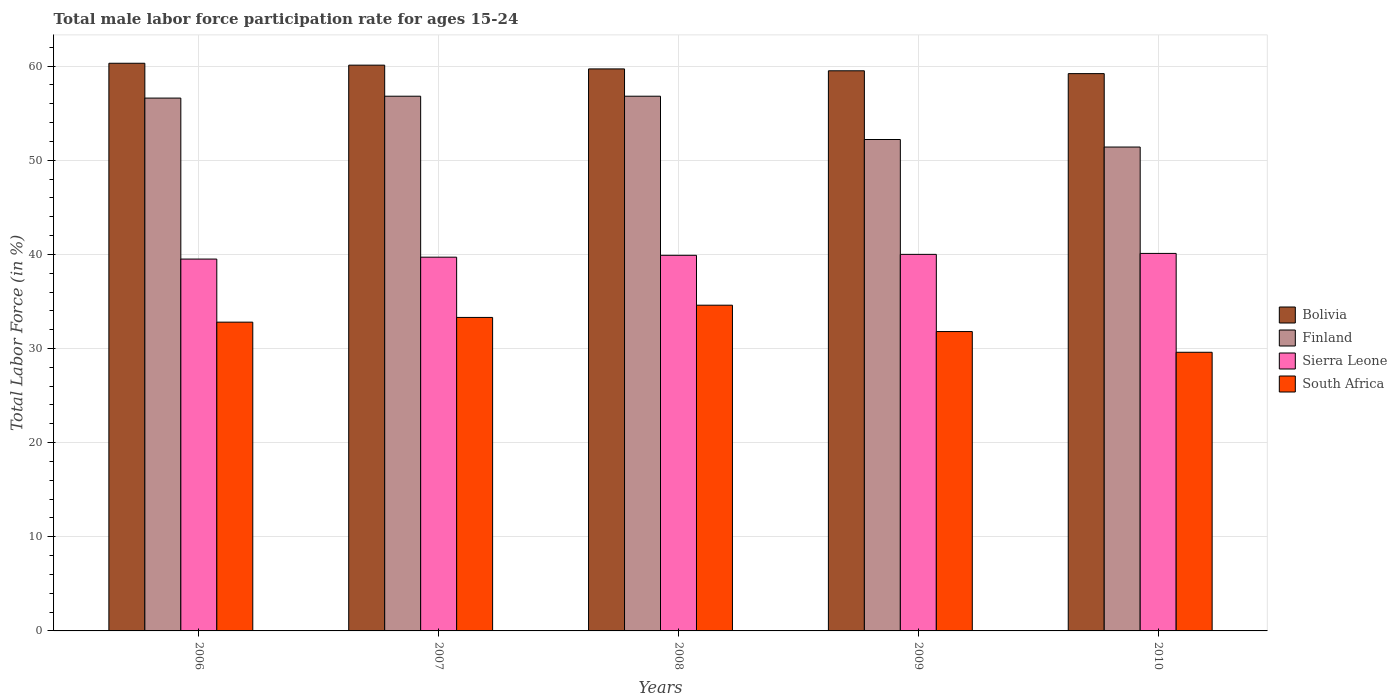How many different coloured bars are there?
Offer a terse response. 4. How many bars are there on the 1st tick from the left?
Provide a succinct answer. 4. How many bars are there on the 1st tick from the right?
Offer a very short reply. 4. What is the label of the 2nd group of bars from the left?
Your response must be concise. 2007. What is the male labor force participation rate in Finland in 2008?
Keep it short and to the point. 56.8. Across all years, what is the maximum male labor force participation rate in South Africa?
Offer a terse response. 34.6. Across all years, what is the minimum male labor force participation rate in Finland?
Give a very brief answer. 51.4. What is the total male labor force participation rate in Finland in the graph?
Ensure brevity in your answer.  273.8. What is the difference between the male labor force participation rate in Bolivia in 2006 and that in 2007?
Your answer should be compact. 0.2. What is the difference between the male labor force participation rate in Finland in 2008 and the male labor force participation rate in Bolivia in 2009?
Ensure brevity in your answer.  -2.7. What is the average male labor force participation rate in South Africa per year?
Provide a short and direct response. 32.42. In the year 2007, what is the difference between the male labor force participation rate in Finland and male labor force participation rate in Bolivia?
Ensure brevity in your answer.  -3.3. What is the ratio of the male labor force participation rate in Bolivia in 2008 to that in 2010?
Offer a very short reply. 1.01. Is the male labor force participation rate in Sierra Leone in 2006 less than that in 2009?
Your response must be concise. Yes. What is the difference between the highest and the second highest male labor force participation rate in Bolivia?
Your answer should be compact. 0.2. What is the difference between the highest and the lowest male labor force participation rate in South Africa?
Offer a terse response. 5. Is the sum of the male labor force participation rate in South Africa in 2009 and 2010 greater than the maximum male labor force participation rate in Bolivia across all years?
Ensure brevity in your answer.  Yes. Is it the case that in every year, the sum of the male labor force participation rate in Bolivia and male labor force participation rate in Sierra Leone is greater than the sum of male labor force participation rate in Finland and male labor force participation rate in South Africa?
Offer a very short reply. No. What does the 2nd bar from the right in 2007 represents?
Keep it short and to the point. Sierra Leone. Is it the case that in every year, the sum of the male labor force participation rate in Bolivia and male labor force participation rate in Finland is greater than the male labor force participation rate in Sierra Leone?
Provide a short and direct response. Yes. How many bars are there?
Provide a succinct answer. 20. How many years are there in the graph?
Ensure brevity in your answer.  5. Are the values on the major ticks of Y-axis written in scientific E-notation?
Ensure brevity in your answer.  No. Does the graph contain any zero values?
Make the answer very short. No. Where does the legend appear in the graph?
Your response must be concise. Center right. How many legend labels are there?
Offer a terse response. 4. What is the title of the graph?
Keep it short and to the point. Total male labor force participation rate for ages 15-24. Does "Lesotho" appear as one of the legend labels in the graph?
Ensure brevity in your answer.  No. What is the label or title of the X-axis?
Provide a succinct answer. Years. What is the Total Labor Force (in %) of Bolivia in 2006?
Your response must be concise. 60.3. What is the Total Labor Force (in %) of Finland in 2006?
Your response must be concise. 56.6. What is the Total Labor Force (in %) in Sierra Leone in 2006?
Your answer should be compact. 39.5. What is the Total Labor Force (in %) of South Africa in 2006?
Provide a succinct answer. 32.8. What is the Total Labor Force (in %) in Bolivia in 2007?
Keep it short and to the point. 60.1. What is the Total Labor Force (in %) of Finland in 2007?
Offer a very short reply. 56.8. What is the Total Labor Force (in %) of Sierra Leone in 2007?
Provide a succinct answer. 39.7. What is the Total Labor Force (in %) of South Africa in 2007?
Provide a short and direct response. 33.3. What is the Total Labor Force (in %) of Bolivia in 2008?
Offer a terse response. 59.7. What is the Total Labor Force (in %) in Finland in 2008?
Make the answer very short. 56.8. What is the Total Labor Force (in %) in Sierra Leone in 2008?
Provide a short and direct response. 39.9. What is the Total Labor Force (in %) of South Africa in 2008?
Ensure brevity in your answer.  34.6. What is the Total Labor Force (in %) in Bolivia in 2009?
Your answer should be very brief. 59.5. What is the Total Labor Force (in %) of Finland in 2009?
Give a very brief answer. 52.2. What is the Total Labor Force (in %) in South Africa in 2009?
Offer a very short reply. 31.8. What is the Total Labor Force (in %) of Bolivia in 2010?
Provide a succinct answer. 59.2. What is the Total Labor Force (in %) in Finland in 2010?
Offer a very short reply. 51.4. What is the Total Labor Force (in %) of Sierra Leone in 2010?
Offer a terse response. 40.1. What is the Total Labor Force (in %) of South Africa in 2010?
Offer a terse response. 29.6. Across all years, what is the maximum Total Labor Force (in %) in Bolivia?
Ensure brevity in your answer.  60.3. Across all years, what is the maximum Total Labor Force (in %) in Finland?
Give a very brief answer. 56.8. Across all years, what is the maximum Total Labor Force (in %) of Sierra Leone?
Your answer should be very brief. 40.1. Across all years, what is the maximum Total Labor Force (in %) in South Africa?
Ensure brevity in your answer.  34.6. Across all years, what is the minimum Total Labor Force (in %) in Bolivia?
Offer a very short reply. 59.2. Across all years, what is the minimum Total Labor Force (in %) in Finland?
Ensure brevity in your answer.  51.4. Across all years, what is the minimum Total Labor Force (in %) of Sierra Leone?
Your answer should be very brief. 39.5. Across all years, what is the minimum Total Labor Force (in %) in South Africa?
Give a very brief answer. 29.6. What is the total Total Labor Force (in %) in Bolivia in the graph?
Keep it short and to the point. 298.8. What is the total Total Labor Force (in %) of Finland in the graph?
Offer a very short reply. 273.8. What is the total Total Labor Force (in %) of Sierra Leone in the graph?
Make the answer very short. 199.2. What is the total Total Labor Force (in %) in South Africa in the graph?
Provide a short and direct response. 162.1. What is the difference between the Total Labor Force (in %) in Sierra Leone in 2006 and that in 2007?
Keep it short and to the point. -0.2. What is the difference between the Total Labor Force (in %) in South Africa in 2006 and that in 2007?
Ensure brevity in your answer.  -0.5. What is the difference between the Total Labor Force (in %) in Finland in 2006 and that in 2008?
Make the answer very short. -0.2. What is the difference between the Total Labor Force (in %) in Bolivia in 2006 and that in 2009?
Offer a very short reply. 0.8. What is the difference between the Total Labor Force (in %) in Finland in 2006 and that in 2009?
Offer a very short reply. 4.4. What is the difference between the Total Labor Force (in %) of South Africa in 2006 and that in 2009?
Provide a short and direct response. 1. What is the difference between the Total Labor Force (in %) of Bolivia in 2006 and that in 2010?
Make the answer very short. 1.1. What is the difference between the Total Labor Force (in %) in South Africa in 2006 and that in 2010?
Your answer should be compact. 3.2. What is the difference between the Total Labor Force (in %) in Bolivia in 2007 and that in 2008?
Offer a terse response. 0.4. What is the difference between the Total Labor Force (in %) in Sierra Leone in 2007 and that in 2008?
Provide a short and direct response. -0.2. What is the difference between the Total Labor Force (in %) in Bolivia in 2007 and that in 2009?
Your answer should be very brief. 0.6. What is the difference between the Total Labor Force (in %) in Finland in 2007 and that in 2009?
Offer a very short reply. 4.6. What is the difference between the Total Labor Force (in %) in South Africa in 2007 and that in 2009?
Your answer should be compact. 1.5. What is the difference between the Total Labor Force (in %) in Finland in 2007 and that in 2010?
Give a very brief answer. 5.4. What is the difference between the Total Labor Force (in %) in Sierra Leone in 2007 and that in 2010?
Provide a succinct answer. -0.4. What is the difference between the Total Labor Force (in %) in South Africa in 2007 and that in 2010?
Your answer should be compact. 3.7. What is the difference between the Total Labor Force (in %) of Sierra Leone in 2008 and that in 2009?
Your answer should be compact. -0.1. What is the difference between the Total Labor Force (in %) in South Africa in 2008 and that in 2009?
Your answer should be very brief. 2.8. What is the difference between the Total Labor Force (in %) of Bolivia in 2008 and that in 2010?
Your answer should be compact. 0.5. What is the difference between the Total Labor Force (in %) in Finland in 2008 and that in 2010?
Provide a short and direct response. 5.4. What is the difference between the Total Labor Force (in %) of Sierra Leone in 2008 and that in 2010?
Provide a succinct answer. -0.2. What is the difference between the Total Labor Force (in %) of South Africa in 2008 and that in 2010?
Your response must be concise. 5. What is the difference between the Total Labor Force (in %) of Finland in 2009 and that in 2010?
Provide a succinct answer. 0.8. What is the difference between the Total Labor Force (in %) of South Africa in 2009 and that in 2010?
Your answer should be compact. 2.2. What is the difference between the Total Labor Force (in %) in Bolivia in 2006 and the Total Labor Force (in %) in Finland in 2007?
Your response must be concise. 3.5. What is the difference between the Total Labor Force (in %) of Bolivia in 2006 and the Total Labor Force (in %) of Sierra Leone in 2007?
Provide a short and direct response. 20.6. What is the difference between the Total Labor Force (in %) of Bolivia in 2006 and the Total Labor Force (in %) of South Africa in 2007?
Your answer should be compact. 27. What is the difference between the Total Labor Force (in %) of Finland in 2006 and the Total Labor Force (in %) of South Africa in 2007?
Your response must be concise. 23.3. What is the difference between the Total Labor Force (in %) of Sierra Leone in 2006 and the Total Labor Force (in %) of South Africa in 2007?
Your response must be concise. 6.2. What is the difference between the Total Labor Force (in %) in Bolivia in 2006 and the Total Labor Force (in %) in Sierra Leone in 2008?
Provide a short and direct response. 20.4. What is the difference between the Total Labor Force (in %) of Bolivia in 2006 and the Total Labor Force (in %) of South Africa in 2008?
Ensure brevity in your answer.  25.7. What is the difference between the Total Labor Force (in %) of Sierra Leone in 2006 and the Total Labor Force (in %) of South Africa in 2008?
Your answer should be very brief. 4.9. What is the difference between the Total Labor Force (in %) of Bolivia in 2006 and the Total Labor Force (in %) of Sierra Leone in 2009?
Your answer should be compact. 20.3. What is the difference between the Total Labor Force (in %) in Finland in 2006 and the Total Labor Force (in %) in Sierra Leone in 2009?
Ensure brevity in your answer.  16.6. What is the difference between the Total Labor Force (in %) in Finland in 2006 and the Total Labor Force (in %) in South Africa in 2009?
Make the answer very short. 24.8. What is the difference between the Total Labor Force (in %) of Bolivia in 2006 and the Total Labor Force (in %) of Sierra Leone in 2010?
Give a very brief answer. 20.2. What is the difference between the Total Labor Force (in %) in Bolivia in 2006 and the Total Labor Force (in %) in South Africa in 2010?
Your answer should be very brief. 30.7. What is the difference between the Total Labor Force (in %) in Finland in 2006 and the Total Labor Force (in %) in South Africa in 2010?
Offer a terse response. 27. What is the difference between the Total Labor Force (in %) in Sierra Leone in 2006 and the Total Labor Force (in %) in South Africa in 2010?
Give a very brief answer. 9.9. What is the difference between the Total Labor Force (in %) in Bolivia in 2007 and the Total Labor Force (in %) in Finland in 2008?
Offer a terse response. 3.3. What is the difference between the Total Labor Force (in %) of Bolivia in 2007 and the Total Labor Force (in %) of Sierra Leone in 2008?
Make the answer very short. 20.2. What is the difference between the Total Labor Force (in %) of Bolivia in 2007 and the Total Labor Force (in %) of South Africa in 2008?
Your answer should be compact. 25.5. What is the difference between the Total Labor Force (in %) in Finland in 2007 and the Total Labor Force (in %) in South Africa in 2008?
Make the answer very short. 22.2. What is the difference between the Total Labor Force (in %) in Sierra Leone in 2007 and the Total Labor Force (in %) in South Africa in 2008?
Your answer should be compact. 5.1. What is the difference between the Total Labor Force (in %) of Bolivia in 2007 and the Total Labor Force (in %) of Sierra Leone in 2009?
Provide a short and direct response. 20.1. What is the difference between the Total Labor Force (in %) of Bolivia in 2007 and the Total Labor Force (in %) of South Africa in 2009?
Your answer should be compact. 28.3. What is the difference between the Total Labor Force (in %) of Finland in 2007 and the Total Labor Force (in %) of Sierra Leone in 2009?
Ensure brevity in your answer.  16.8. What is the difference between the Total Labor Force (in %) in Finland in 2007 and the Total Labor Force (in %) in South Africa in 2009?
Your answer should be very brief. 25. What is the difference between the Total Labor Force (in %) in Bolivia in 2007 and the Total Labor Force (in %) in Sierra Leone in 2010?
Ensure brevity in your answer.  20. What is the difference between the Total Labor Force (in %) of Bolivia in 2007 and the Total Labor Force (in %) of South Africa in 2010?
Offer a very short reply. 30.5. What is the difference between the Total Labor Force (in %) in Finland in 2007 and the Total Labor Force (in %) in South Africa in 2010?
Provide a short and direct response. 27.2. What is the difference between the Total Labor Force (in %) of Sierra Leone in 2007 and the Total Labor Force (in %) of South Africa in 2010?
Ensure brevity in your answer.  10.1. What is the difference between the Total Labor Force (in %) of Bolivia in 2008 and the Total Labor Force (in %) of Finland in 2009?
Your answer should be very brief. 7.5. What is the difference between the Total Labor Force (in %) of Bolivia in 2008 and the Total Labor Force (in %) of South Africa in 2009?
Your response must be concise. 27.9. What is the difference between the Total Labor Force (in %) in Finland in 2008 and the Total Labor Force (in %) in South Africa in 2009?
Your answer should be compact. 25. What is the difference between the Total Labor Force (in %) in Sierra Leone in 2008 and the Total Labor Force (in %) in South Africa in 2009?
Your response must be concise. 8.1. What is the difference between the Total Labor Force (in %) of Bolivia in 2008 and the Total Labor Force (in %) of Sierra Leone in 2010?
Provide a succinct answer. 19.6. What is the difference between the Total Labor Force (in %) in Bolivia in 2008 and the Total Labor Force (in %) in South Africa in 2010?
Offer a very short reply. 30.1. What is the difference between the Total Labor Force (in %) of Finland in 2008 and the Total Labor Force (in %) of South Africa in 2010?
Give a very brief answer. 27.2. What is the difference between the Total Labor Force (in %) of Sierra Leone in 2008 and the Total Labor Force (in %) of South Africa in 2010?
Give a very brief answer. 10.3. What is the difference between the Total Labor Force (in %) of Bolivia in 2009 and the Total Labor Force (in %) of Finland in 2010?
Ensure brevity in your answer.  8.1. What is the difference between the Total Labor Force (in %) of Bolivia in 2009 and the Total Labor Force (in %) of South Africa in 2010?
Your answer should be very brief. 29.9. What is the difference between the Total Labor Force (in %) of Finland in 2009 and the Total Labor Force (in %) of Sierra Leone in 2010?
Give a very brief answer. 12.1. What is the difference between the Total Labor Force (in %) of Finland in 2009 and the Total Labor Force (in %) of South Africa in 2010?
Offer a very short reply. 22.6. What is the average Total Labor Force (in %) of Bolivia per year?
Make the answer very short. 59.76. What is the average Total Labor Force (in %) in Finland per year?
Your answer should be compact. 54.76. What is the average Total Labor Force (in %) in Sierra Leone per year?
Your response must be concise. 39.84. What is the average Total Labor Force (in %) of South Africa per year?
Keep it short and to the point. 32.42. In the year 2006, what is the difference between the Total Labor Force (in %) in Bolivia and Total Labor Force (in %) in Finland?
Make the answer very short. 3.7. In the year 2006, what is the difference between the Total Labor Force (in %) of Bolivia and Total Labor Force (in %) of Sierra Leone?
Your answer should be compact. 20.8. In the year 2006, what is the difference between the Total Labor Force (in %) of Bolivia and Total Labor Force (in %) of South Africa?
Provide a short and direct response. 27.5. In the year 2006, what is the difference between the Total Labor Force (in %) in Finland and Total Labor Force (in %) in South Africa?
Provide a succinct answer. 23.8. In the year 2006, what is the difference between the Total Labor Force (in %) in Sierra Leone and Total Labor Force (in %) in South Africa?
Your response must be concise. 6.7. In the year 2007, what is the difference between the Total Labor Force (in %) of Bolivia and Total Labor Force (in %) of Sierra Leone?
Offer a terse response. 20.4. In the year 2007, what is the difference between the Total Labor Force (in %) in Bolivia and Total Labor Force (in %) in South Africa?
Make the answer very short. 26.8. In the year 2007, what is the difference between the Total Labor Force (in %) in Finland and Total Labor Force (in %) in Sierra Leone?
Give a very brief answer. 17.1. In the year 2008, what is the difference between the Total Labor Force (in %) in Bolivia and Total Labor Force (in %) in Finland?
Your answer should be very brief. 2.9. In the year 2008, what is the difference between the Total Labor Force (in %) in Bolivia and Total Labor Force (in %) in Sierra Leone?
Your answer should be very brief. 19.8. In the year 2008, what is the difference between the Total Labor Force (in %) in Bolivia and Total Labor Force (in %) in South Africa?
Provide a short and direct response. 25.1. In the year 2008, what is the difference between the Total Labor Force (in %) in Finland and Total Labor Force (in %) in Sierra Leone?
Offer a very short reply. 16.9. In the year 2009, what is the difference between the Total Labor Force (in %) of Bolivia and Total Labor Force (in %) of South Africa?
Offer a very short reply. 27.7. In the year 2009, what is the difference between the Total Labor Force (in %) of Finland and Total Labor Force (in %) of South Africa?
Keep it short and to the point. 20.4. In the year 2010, what is the difference between the Total Labor Force (in %) in Bolivia and Total Labor Force (in %) in Finland?
Keep it short and to the point. 7.8. In the year 2010, what is the difference between the Total Labor Force (in %) in Bolivia and Total Labor Force (in %) in Sierra Leone?
Your answer should be compact. 19.1. In the year 2010, what is the difference between the Total Labor Force (in %) in Bolivia and Total Labor Force (in %) in South Africa?
Offer a very short reply. 29.6. In the year 2010, what is the difference between the Total Labor Force (in %) of Finland and Total Labor Force (in %) of South Africa?
Provide a short and direct response. 21.8. In the year 2010, what is the difference between the Total Labor Force (in %) of Sierra Leone and Total Labor Force (in %) of South Africa?
Your answer should be very brief. 10.5. What is the ratio of the Total Labor Force (in %) in Bolivia in 2006 to that in 2007?
Keep it short and to the point. 1. What is the ratio of the Total Labor Force (in %) of Sierra Leone in 2006 to that in 2008?
Your answer should be compact. 0.99. What is the ratio of the Total Labor Force (in %) in South Africa in 2006 to that in 2008?
Provide a succinct answer. 0.95. What is the ratio of the Total Labor Force (in %) of Bolivia in 2006 to that in 2009?
Ensure brevity in your answer.  1.01. What is the ratio of the Total Labor Force (in %) in Finland in 2006 to that in 2009?
Provide a succinct answer. 1.08. What is the ratio of the Total Labor Force (in %) of Sierra Leone in 2006 to that in 2009?
Your answer should be compact. 0.99. What is the ratio of the Total Labor Force (in %) in South Africa in 2006 to that in 2009?
Offer a terse response. 1.03. What is the ratio of the Total Labor Force (in %) in Bolivia in 2006 to that in 2010?
Provide a short and direct response. 1.02. What is the ratio of the Total Labor Force (in %) in Finland in 2006 to that in 2010?
Give a very brief answer. 1.1. What is the ratio of the Total Labor Force (in %) of South Africa in 2006 to that in 2010?
Ensure brevity in your answer.  1.11. What is the ratio of the Total Labor Force (in %) in Bolivia in 2007 to that in 2008?
Give a very brief answer. 1.01. What is the ratio of the Total Labor Force (in %) of Sierra Leone in 2007 to that in 2008?
Provide a succinct answer. 0.99. What is the ratio of the Total Labor Force (in %) of South Africa in 2007 to that in 2008?
Provide a succinct answer. 0.96. What is the ratio of the Total Labor Force (in %) in Bolivia in 2007 to that in 2009?
Offer a very short reply. 1.01. What is the ratio of the Total Labor Force (in %) of Finland in 2007 to that in 2009?
Make the answer very short. 1.09. What is the ratio of the Total Labor Force (in %) in Sierra Leone in 2007 to that in 2009?
Make the answer very short. 0.99. What is the ratio of the Total Labor Force (in %) of South Africa in 2007 to that in 2009?
Keep it short and to the point. 1.05. What is the ratio of the Total Labor Force (in %) of Bolivia in 2007 to that in 2010?
Ensure brevity in your answer.  1.02. What is the ratio of the Total Labor Force (in %) of Finland in 2007 to that in 2010?
Give a very brief answer. 1.11. What is the ratio of the Total Labor Force (in %) of Sierra Leone in 2007 to that in 2010?
Keep it short and to the point. 0.99. What is the ratio of the Total Labor Force (in %) in Bolivia in 2008 to that in 2009?
Your answer should be very brief. 1. What is the ratio of the Total Labor Force (in %) in Finland in 2008 to that in 2009?
Your answer should be very brief. 1.09. What is the ratio of the Total Labor Force (in %) of Sierra Leone in 2008 to that in 2009?
Your response must be concise. 1. What is the ratio of the Total Labor Force (in %) in South Africa in 2008 to that in 2009?
Give a very brief answer. 1.09. What is the ratio of the Total Labor Force (in %) of Bolivia in 2008 to that in 2010?
Provide a short and direct response. 1.01. What is the ratio of the Total Labor Force (in %) in Finland in 2008 to that in 2010?
Offer a terse response. 1.11. What is the ratio of the Total Labor Force (in %) of South Africa in 2008 to that in 2010?
Your answer should be compact. 1.17. What is the ratio of the Total Labor Force (in %) of Finland in 2009 to that in 2010?
Ensure brevity in your answer.  1.02. What is the ratio of the Total Labor Force (in %) of South Africa in 2009 to that in 2010?
Your answer should be compact. 1.07. What is the difference between the highest and the second highest Total Labor Force (in %) in Sierra Leone?
Offer a very short reply. 0.1. What is the difference between the highest and the second highest Total Labor Force (in %) in South Africa?
Ensure brevity in your answer.  1.3. What is the difference between the highest and the lowest Total Labor Force (in %) of Bolivia?
Provide a succinct answer. 1.1. 